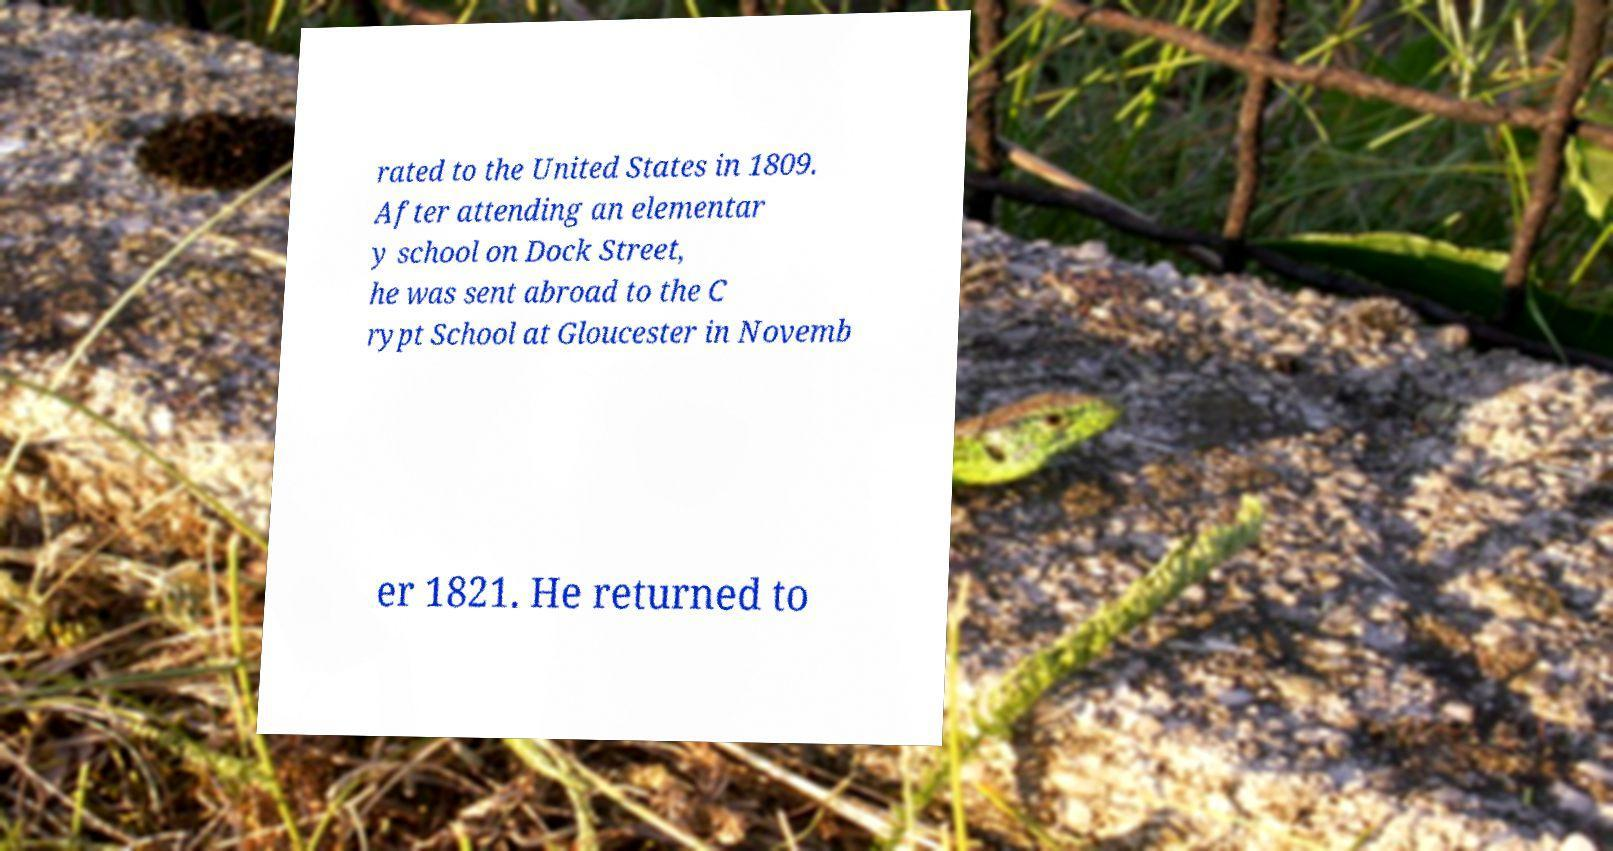For documentation purposes, I need the text within this image transcribed. Could you provide that? rated to the United States in 1809. After attending an elementar y school on Dock Street, he was sent abroad to the C rypt School at Gloucester in Novemb er 1821. He returned to 